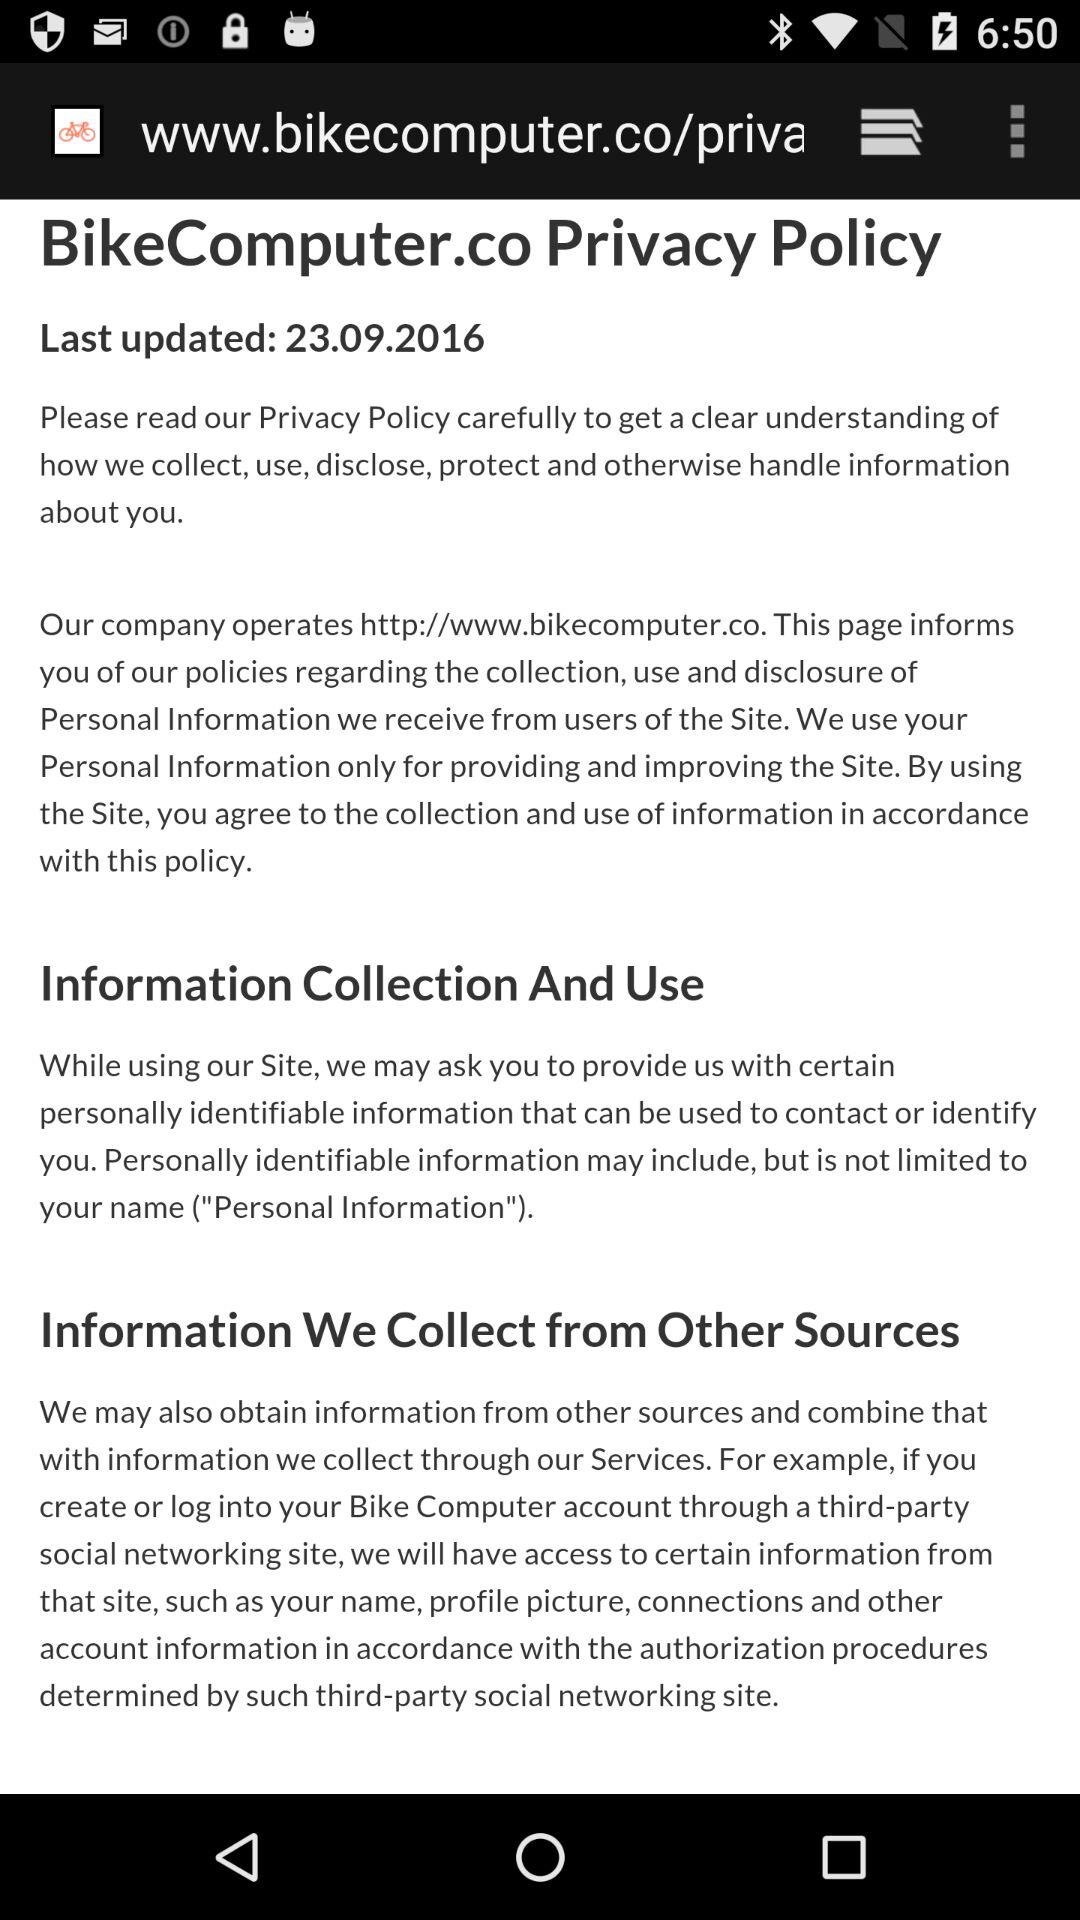When was it last updated? It was last updated on September 23, 2016. 